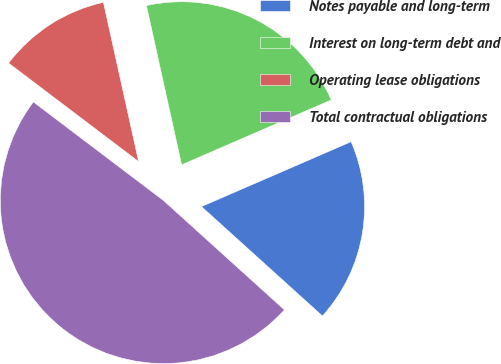Convert chart to OTSL. <chart><loc_0><loc_0><loc_500><loc_500><pie_chart><fcel>Notes payable and long-term<fcel>Interest on long-term debt and<fcel>Operating lease obligations<fcel>Total contractual obligations<nl><fcel>18.21%<fcel>21.95%<fcel>11.22%<fcel>48.61%<nl></chart> 